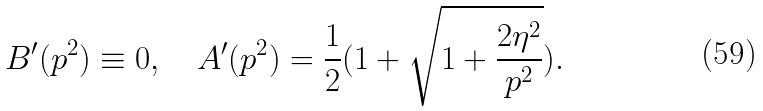<formula> <loc_0><loc_0><loc_500><loc_500>B ^ { \prime } ( p ^ { 2 } ) \equiv 0 , \quad A ^ { \prime } ( p ^ { 2 } ) = \frac { 1 } { 2 } ( 1 + \sqrt { 1 + \frac { 2 \eta ^ { 2 } } { p ^ { 2 } } } ) .</formula> 